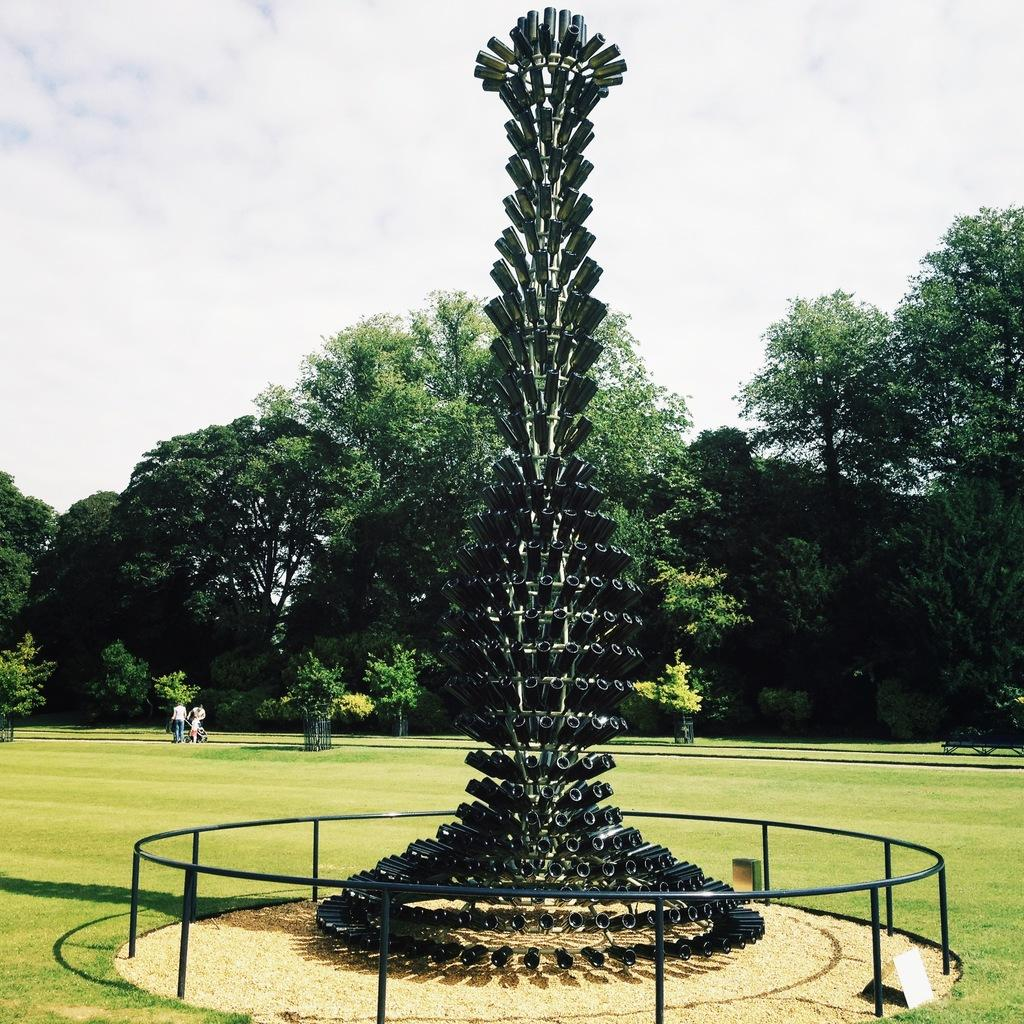What is the setting of the image? The image has an outside view. What can be seen in the foreground of the image? There is a mechanical sculpture in the foreground. What type of natural elements are present in the image? There are trees in the middle of the image. What is visible in the background of the image? The sky is visible in the background. Where is the letter placed in the image? There is no letter present in the image. What type of furniture can be seen in the bedroom in the image? There is no bedroom present in the image. 